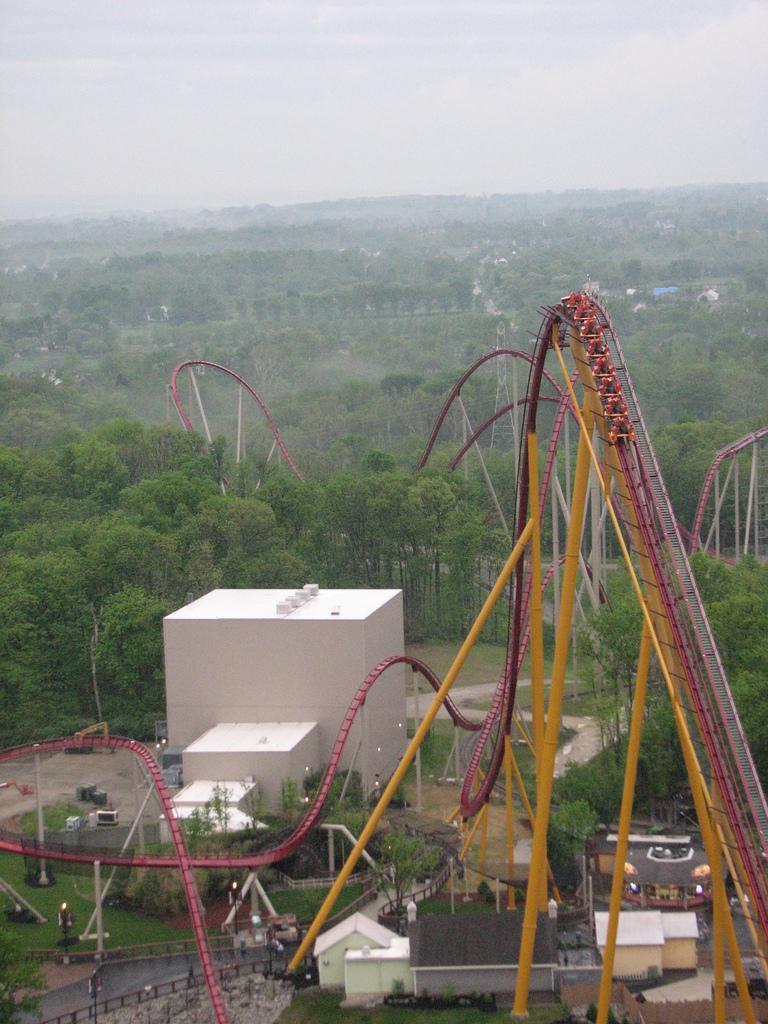Could you give a brief overview of what you see in this image? I n this image I can see a roller coaster, buildings, trees, poles and other objects on the ground. In the background I can see the sky. 